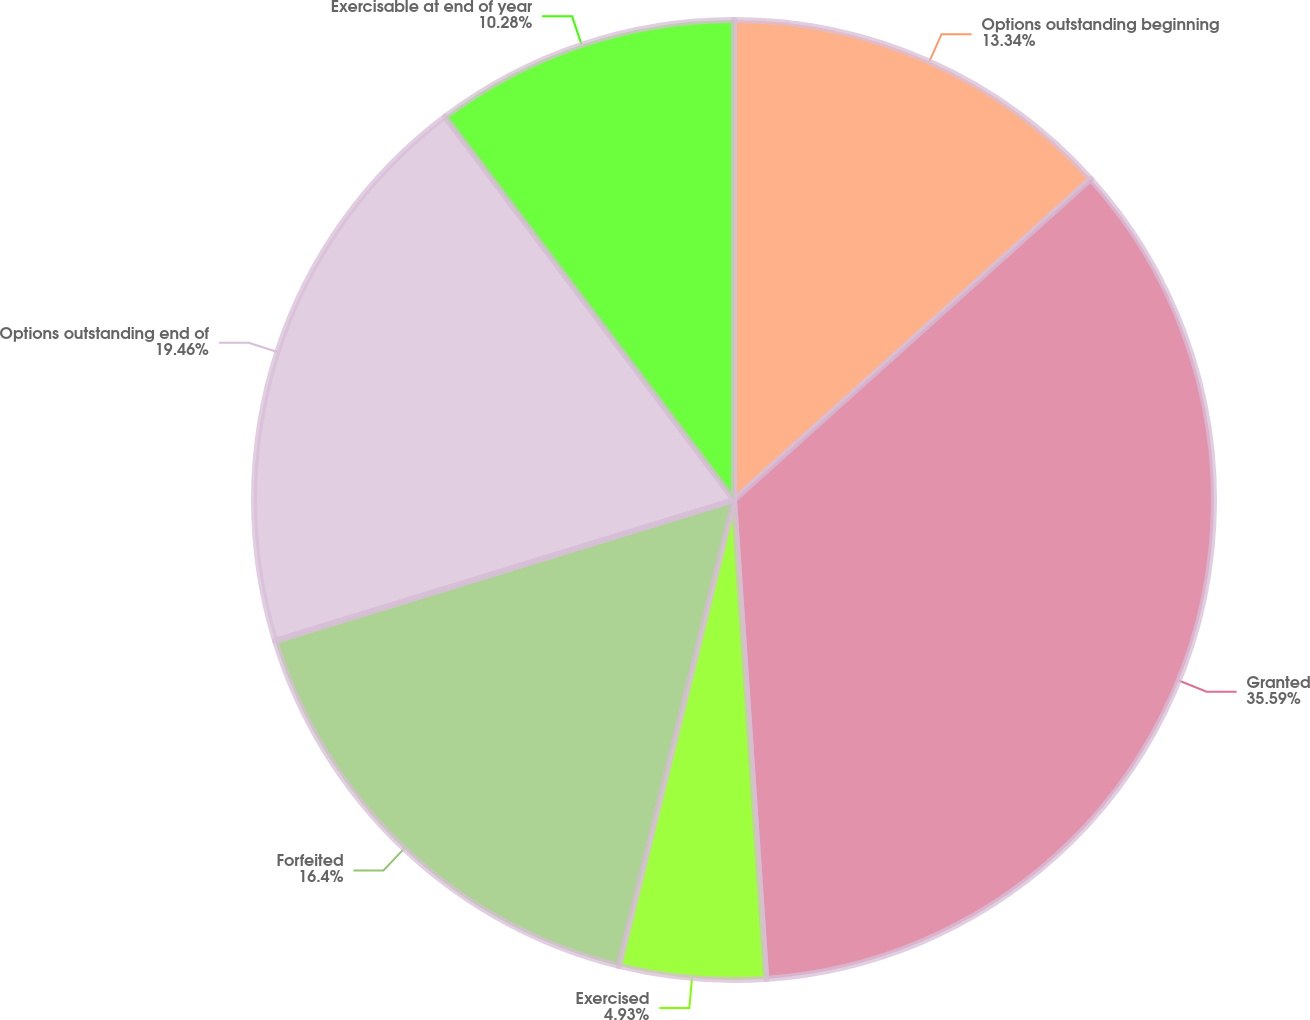<chart> <loc_0><loc_0><loc_500><loc_500><pie_chart><fcel>Options outstanding beginning<fcel>Granted<fcel>Exercised<fcel>Forfeited<fcel>Options outstanding end of<fcel>Exercisable at end of year<nl><fcel>13.34%<fcel>35.59%<fcel>4.93%<fcel>16.4%<fcel>19.46%<fcel>10.28%<nl></chart> 